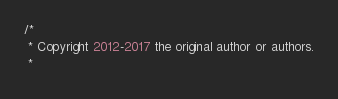Convert code to text. <code><loc_0><loc_0><loc_500><loc_500><_Java_>/*
 * Copyright 2012-2017 the original author or authors.
 *</code> 